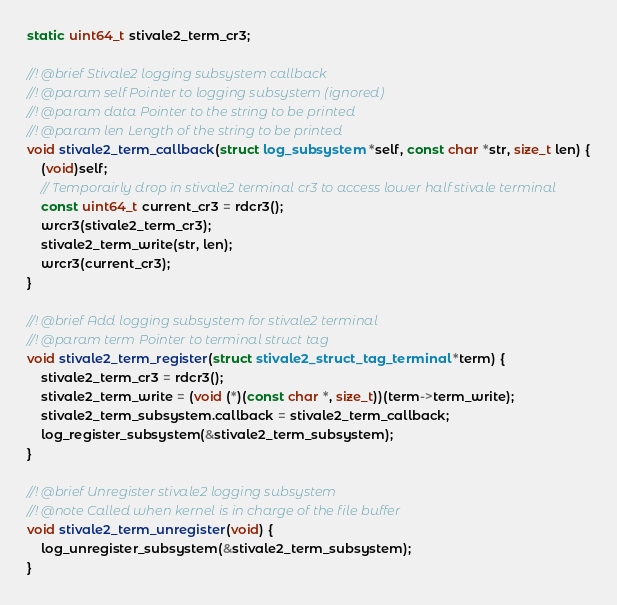<code> <loc_0><loc_0><loc_500><loc_500><_C_>static uint64_t stivale2_term_cr3;

//! @brief Stivale2 logging subsystem callback
//! @param self Pointer to logging subsystem (ignored)
//! @param data Pointer to the string to be printed
//! @param len Length of the string to be printed
void stivale2_term_callback(struct log_subsystem *self, const char *str, size_t len) {
	(void)self;
	// Temporairly drop in stivale2 terminal cr3 to access lower half stivale terminal
	const uint64_t current_cr3 = rdcr3();
	wrcr3(stivale2_term_cr3);
	stivale2_term_write(str, len);
	wrcr3(current_cr3);
}

//! @brief Add logging subsystem for stivale2 terminal
//! @param term Pointer to terminal struct tag
void stivale2_term_register(struct stivale2_struct_tag_terminal *term) {
	stivale2_term_cr3 = rdcr3();
	stivale2_term_write = (void (*)(const char *, size_t))(term->term_write);
	stivale2_term_subsystem.callback = stivale2_term_callback;
	log_register_subsystem(&stivale2_term_subsystem);
}

//! @brief Unregister stivale2 logging subsystem
//! @note Called when kernel is in charge of the file buffer
void stivale2_term_unregister(void) {
	log_unregister_subsystem(&stivale2_term_subsystem);
}
</code> 